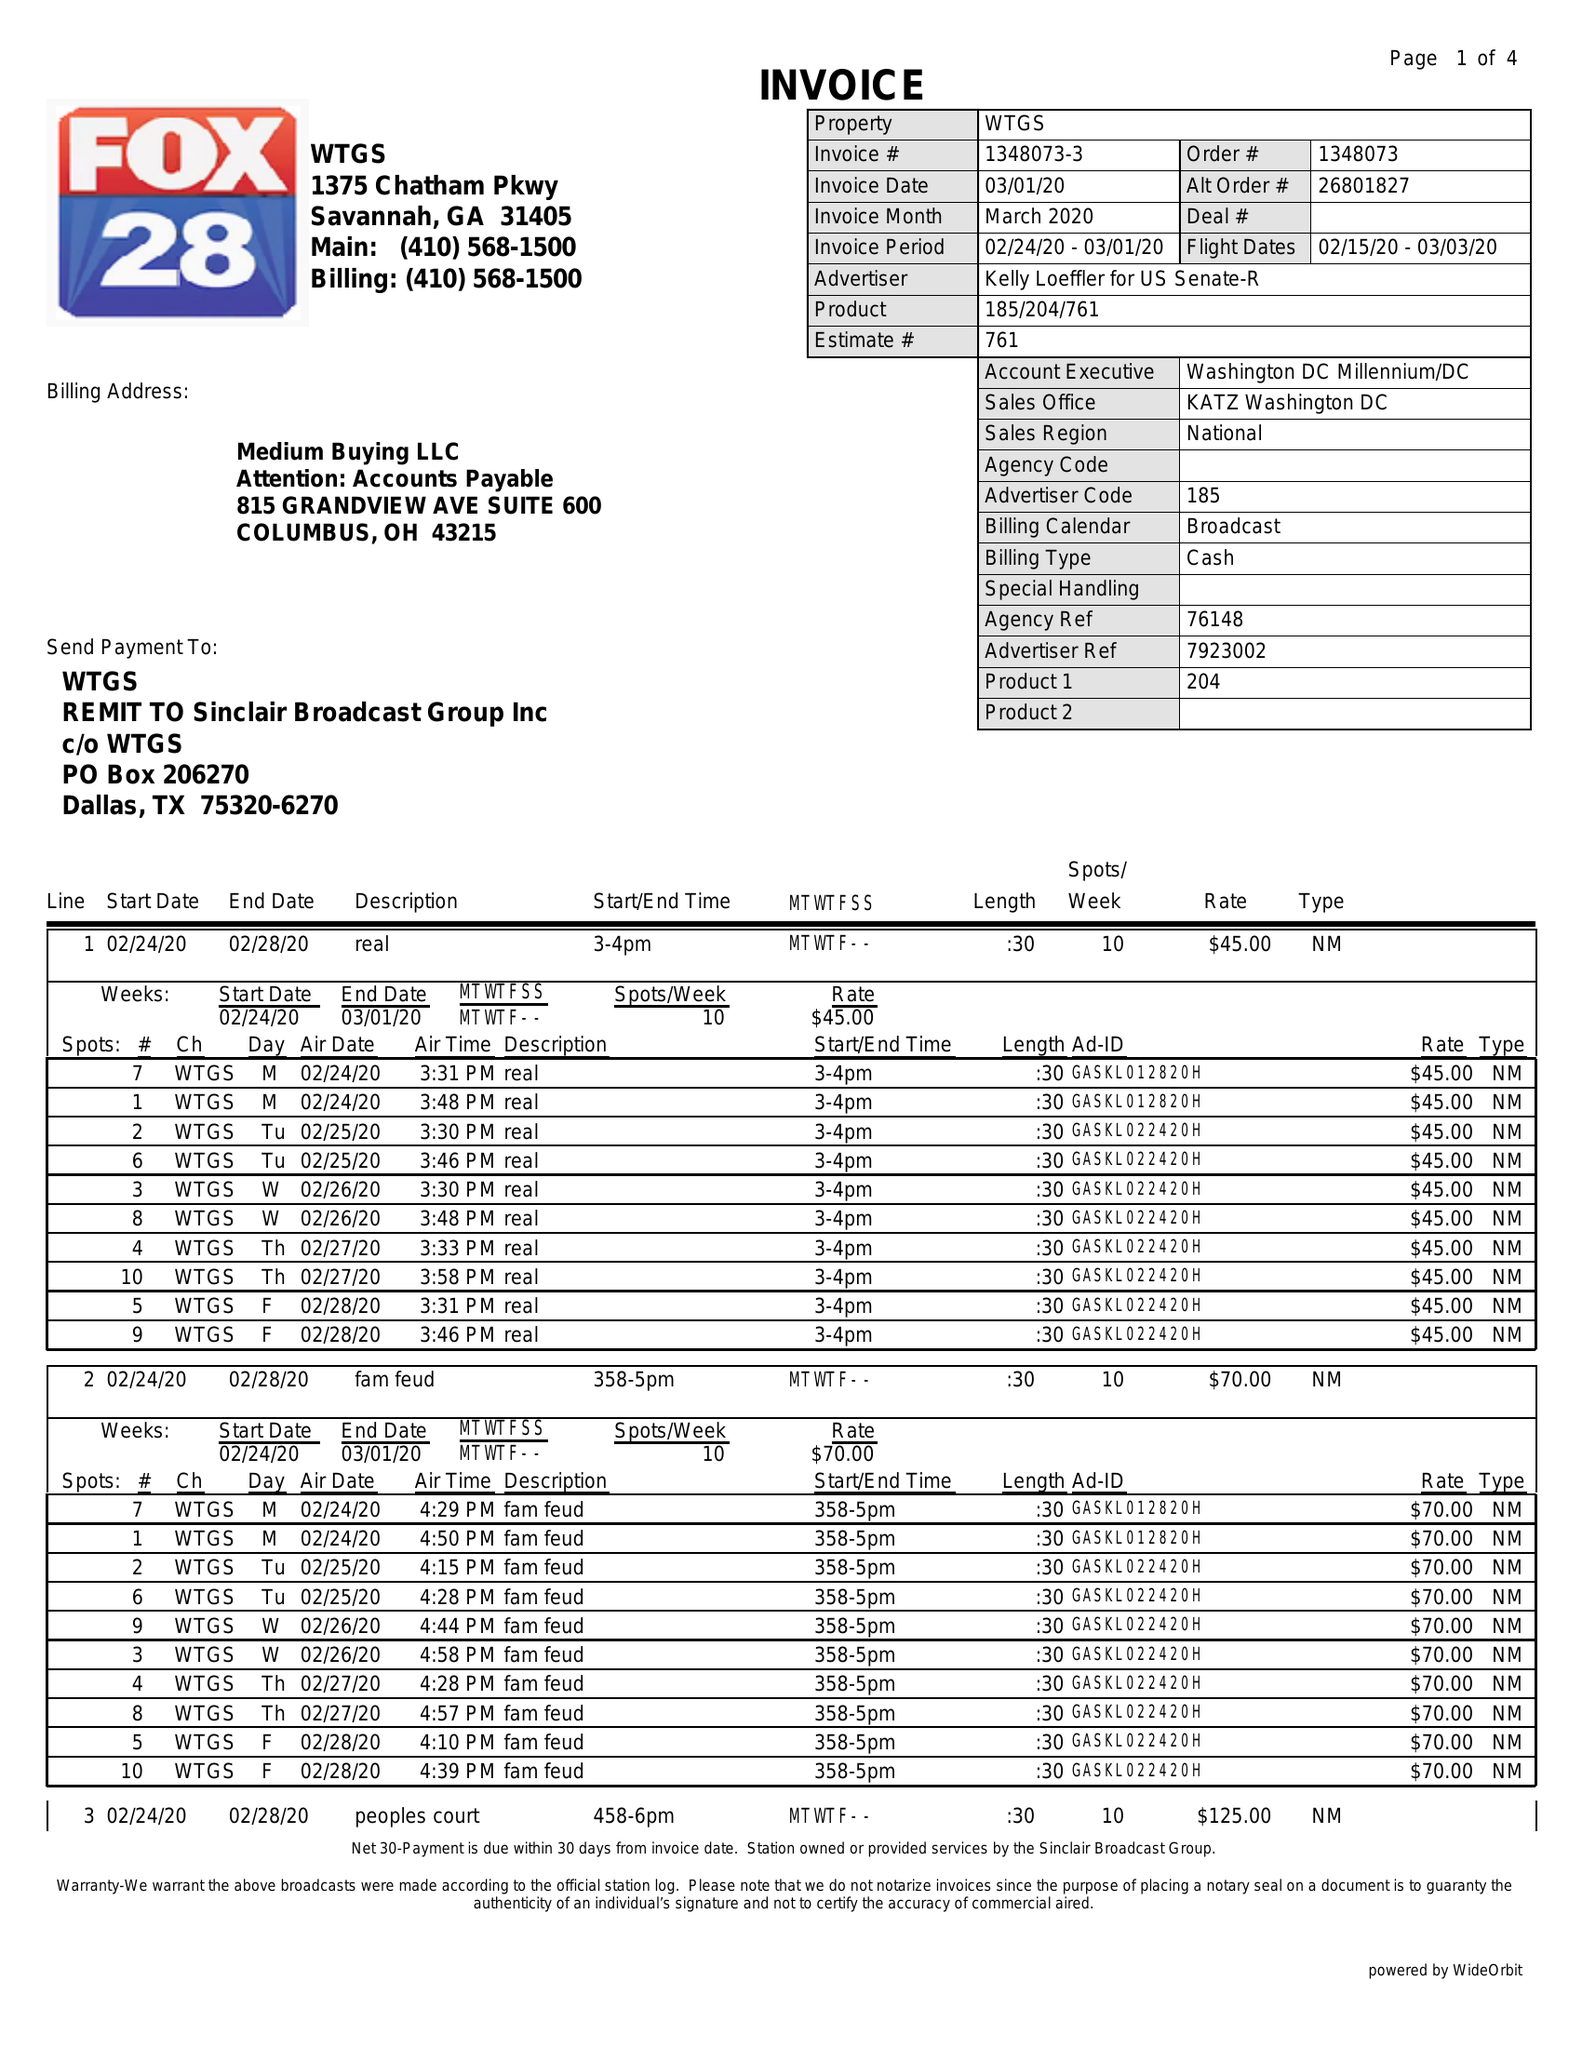What is the value for the flight_to?
Answer the question using a single word or phrase. 03/03/20 